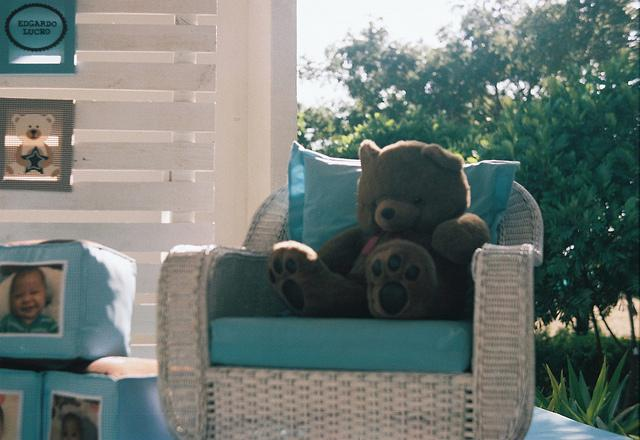How did the bear get there? Please explain your reasoning. placed there. The teddy bear is sitting on a chair. 